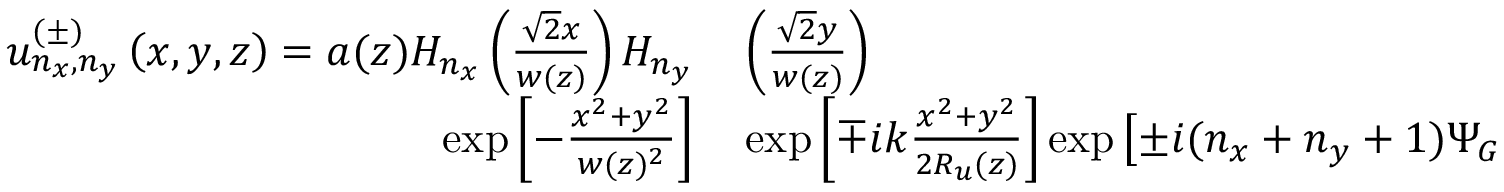<formula> <loc_0><loc_0><loc_500><loc_500>\begin{array} { r l } { u _ { n _ { x } , n _ { y } } ^ { ( \pm ) } \left ( x , y , z \right ) = a ( z ) H _ { n _ { x } } \left ( \frac { \sqrt { 2 } x } { w ( z ) } \right ) H _ { n _ { y } } } & \left ( \frac { \sqrt { 2 } y } { w ( z ) } \right ) } \\ { \exp \left [ - \frac { x ^ { 2 } + y ^ { 2 } } { w ( z ) ^ { 2 } } \right ] } & \exp \left [ \mp i k \frac { x ^ { 2 } + y ^ { 2 } } { 2 R _ { u } ( z ) } \right ] \exp \left [ \pm i ( n _ { x } + n _ { y } + 1 ) \Psi _ { G } \right ] , } \end{array}</formula> 